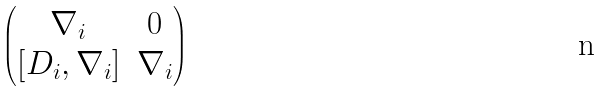<formula> <loc_0><loc_0><loc_500><loc_500>\begin{pmatrix} \nabla _ { i } & 0 \\ [ D _ { i } , \nabla _ { i } ] & \nabla _ { i } \end{pmatrix}</formula> 